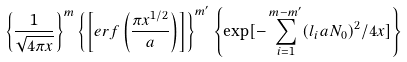Convert formula to latex. <formula><loc_0><loc_0><loc_500><loc_500>\left \{ \frac { 1 } { \sqrt { 4 \pi x } } \right \} ^ { m } \left \{ \left [ e r f \left ( \frac { \pi x ^ { 1 / 2 } } { a } \right ) \right ] \right \} ^ { m ^ { \prime } } \left \{ \exp [ - \sum _ { i = 1 } ^ { m - m ^ { \prime } } ( l _ { i } a N _ { 0 } ) ^ { 2 } / 4 x ] \right \}</formula> 